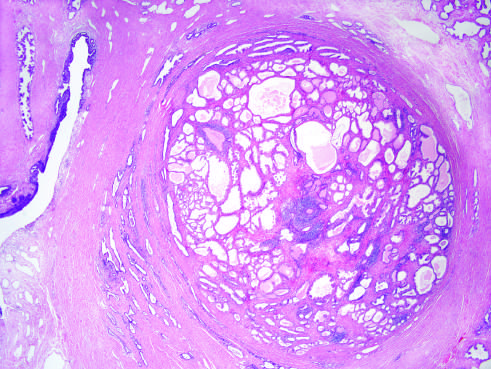what demonstrates a well-demarcated nodule at the right of the field, with a portion of urethra seen to the left?
Answer the question using a single word or phrase. Low-power photomicrograph 